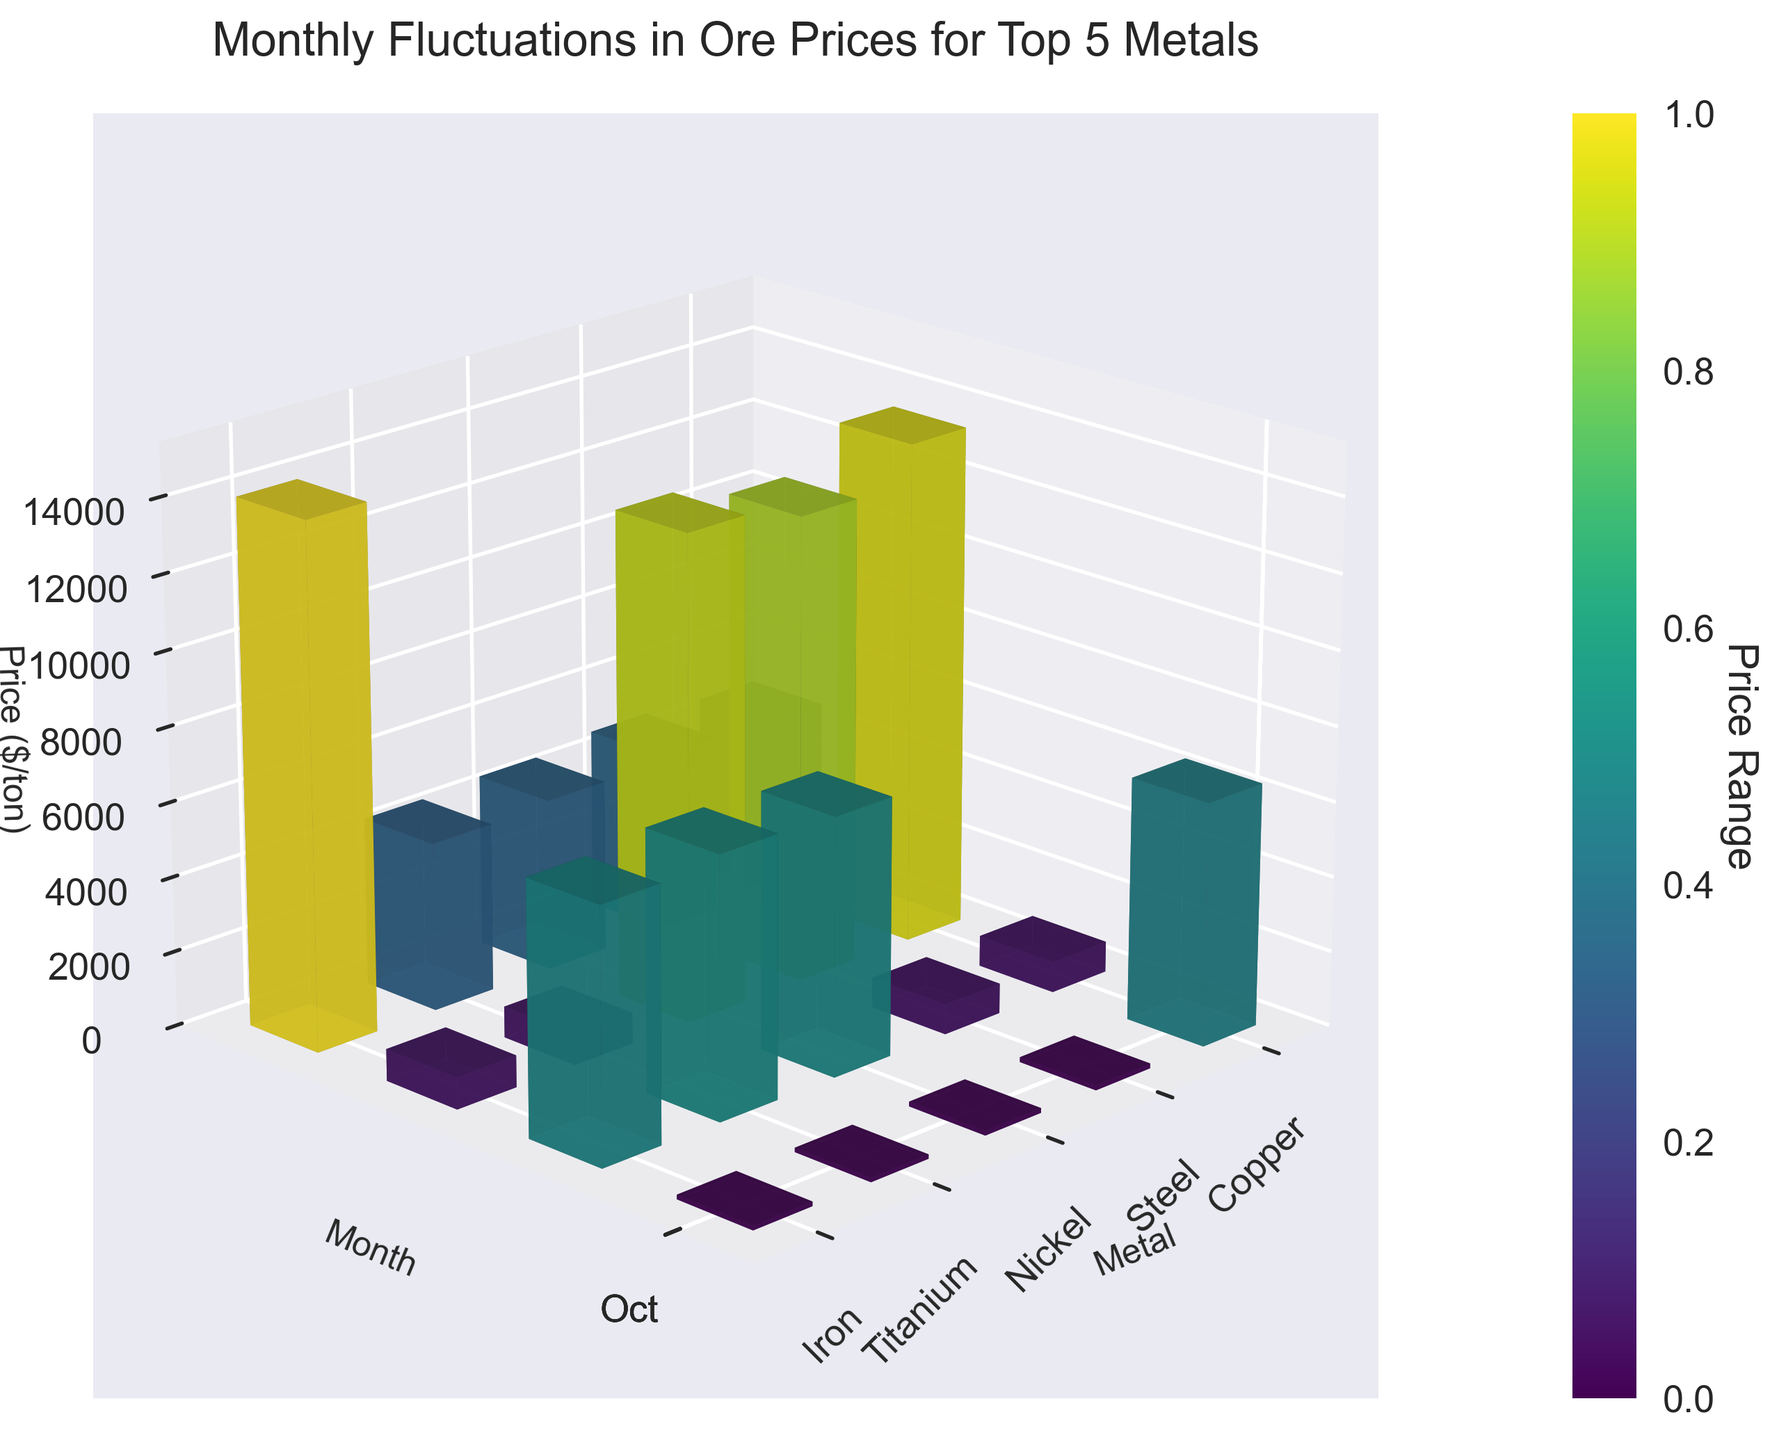What is the title of the 3D bar plot? The title is usually located at the top of the plot. In this case, it's "Monthly Fluctuations in Ore Prices for Top 5 Metals".
Answer: Monthly Fluctuations in Ore Prices for Top 5 Metals Which metal had the highest price in October? To find this, look at the bars corresponding to October and compare their heights. Nickel’s bar is the tallest in October.
Answer: Nickel What is the price of Iron in January? Locate the position of Iron and the month January, then look at the height of the bar. The label shows that it is 120 $/ton.
Answer: 120 $/ton What is the difference in price between Copper in January and Copper in July? Locate the bars for Copper in January (6500 $/ton) and July (7000 $/ton) and subtract the January price from the July price. The difference is 7000 - 6500 = 500 $/ton.
Answer: 500 $/ton Which month has the highest price for Titanium? Check the height of the Titanium bars for each month. July has the tallest bar for Titanium, indicating the highest price.
Answer: July What is the average price of Steel over the year? Add up the monthly prices for Steel (800, 820, 850, and 830) and then divide by 4. The average is (800 + 820 + 850 + 830)/4 = 825 $/ton.
Answer: 825 $/ton How did the price of Nickel change from January to October? Compare the heights of the Nickel bars in January (13000 $/ton) and October (14000 $/ton). Calculate the difference: 14000 - 13000 = 1000 $/ton increase.
Answer: Increased by 1000 $/ton Which metal shows the most significant price increase from April to October? For each metal, check the difference between the April and October bars. Nickel shows the most significant increase: 14000 - 12500 = 1500 $/ton.
Answer: Nickel What is the color range used in the plot and what does it represent? The color gradient used spans different shades and is based on the price values, with darker colors representing higher prices and lighter colors representing lower prices. This is indicated by the color bar on the side.
Answer: Price values How does the price of Titanium in July compare to the price of Steel in July? Look at the heights of the bars for Titanium in July (4800 $/ton) and Steel in July (850 $/ton). The price of Titanium is significantly higher.
Answer: Higher 